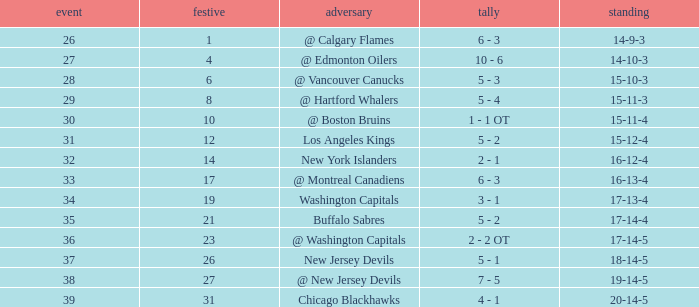Game larger than 34, and a December smaller than 23 had what record? 17-14-4. 